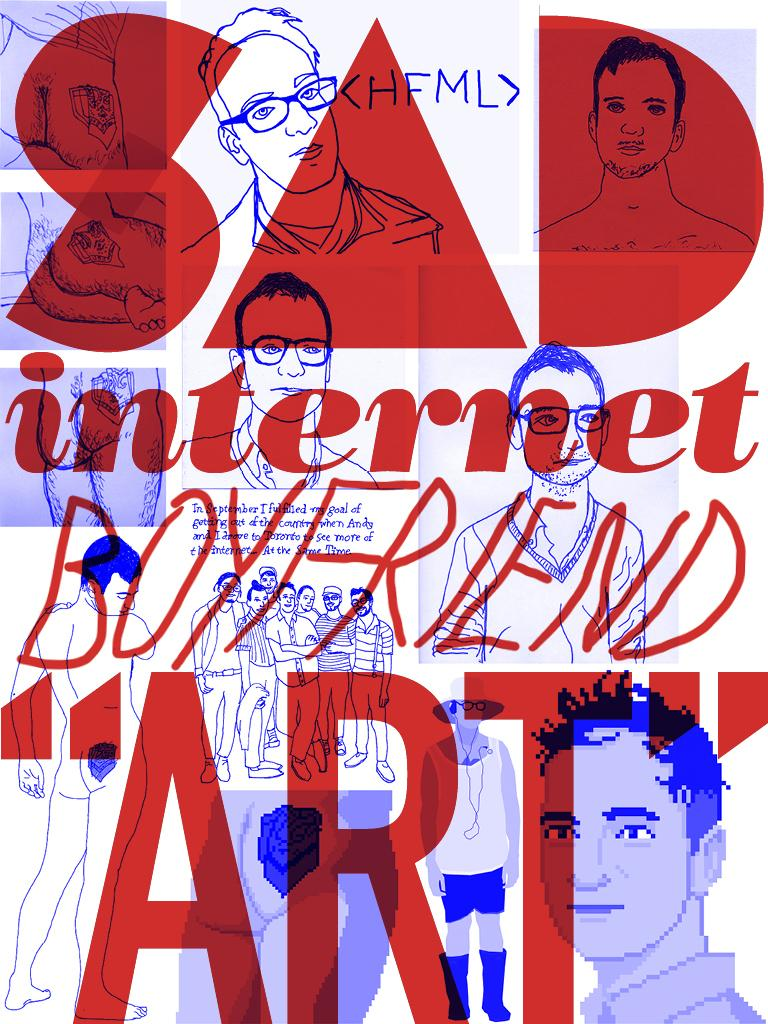What is the main subject of the poster in the image? The main subject of the poster is a drawing of a man. What words are written on the poster in red color? The words "SAD INTERNET BOYFRIEND ART" are written on the poster in red color. What type of cream is being used to draw the man on the poster? There is no mention of cream being used to draw the man on the poster. The drawing is likely made with ink or paint, not cream. 